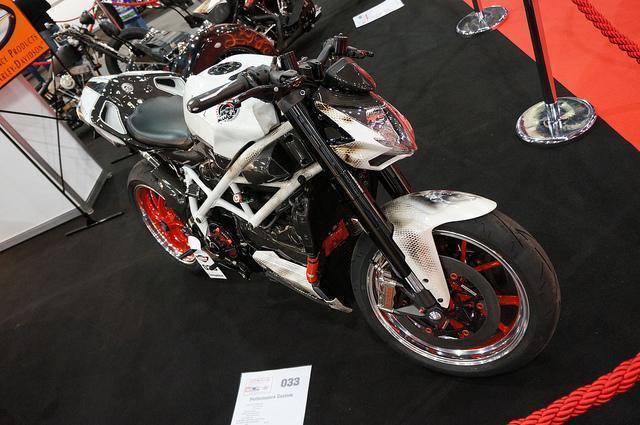How many ropes do you see?
Give a very brief answer. 2. How many motorcycles are in the photo?
Give a very brief answer. 3. 